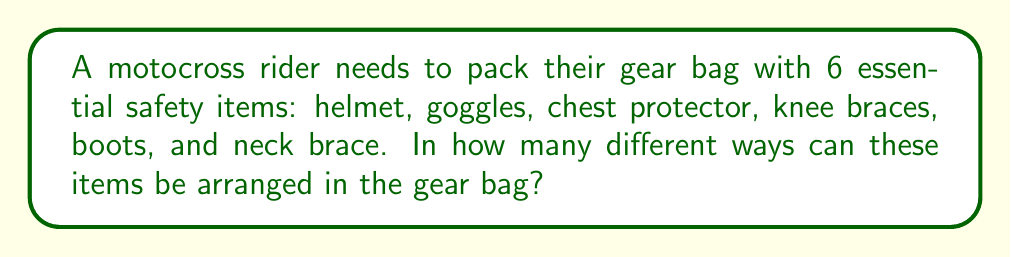Can you answer this question? To solve this problem, we need to use the concept of permutations. Since we are arranging all 6 items and the order matters (as we're packing them into the bag), we use the formula for permutations of n distinct objects:

$$P(n) = n!$$

Where n is the number of objects to be arranged.

In this case:
1. We have 6 distinct safety items.
2. All items must be used.
3. The order of placement matters.

Therefore:

$$n = 6$$

Applying the formula:

$$P(6) = 6!$$

$$6! = 6 \times 5 \times 4 \times 3 \times 2 \times 1 = 720$$

This means there are 720 different ways to arrange the 6 safety items in the gear bag.
Answer: 720 